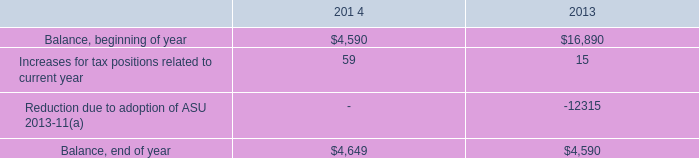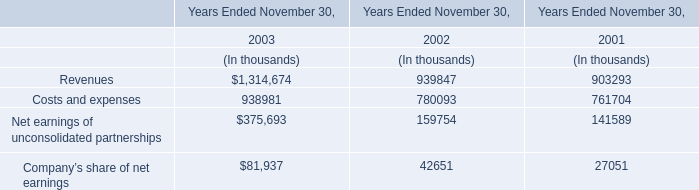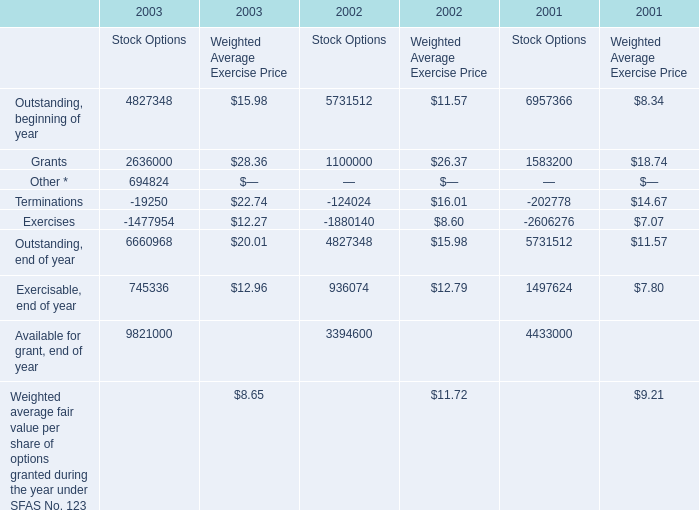what is the proportion of dollars at the beginning of both combined years to dollars at end of both combined years? 
Computations: ((4590 + 16890) / (4649 + 4590))
Answer: 2.32493. 